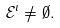Convert formula to latex. <formula><loc_0><loc_0><loc_500><loc_500>{ \mathcal { E } } ^ { \iota } \not = \emptyset .</formula> 